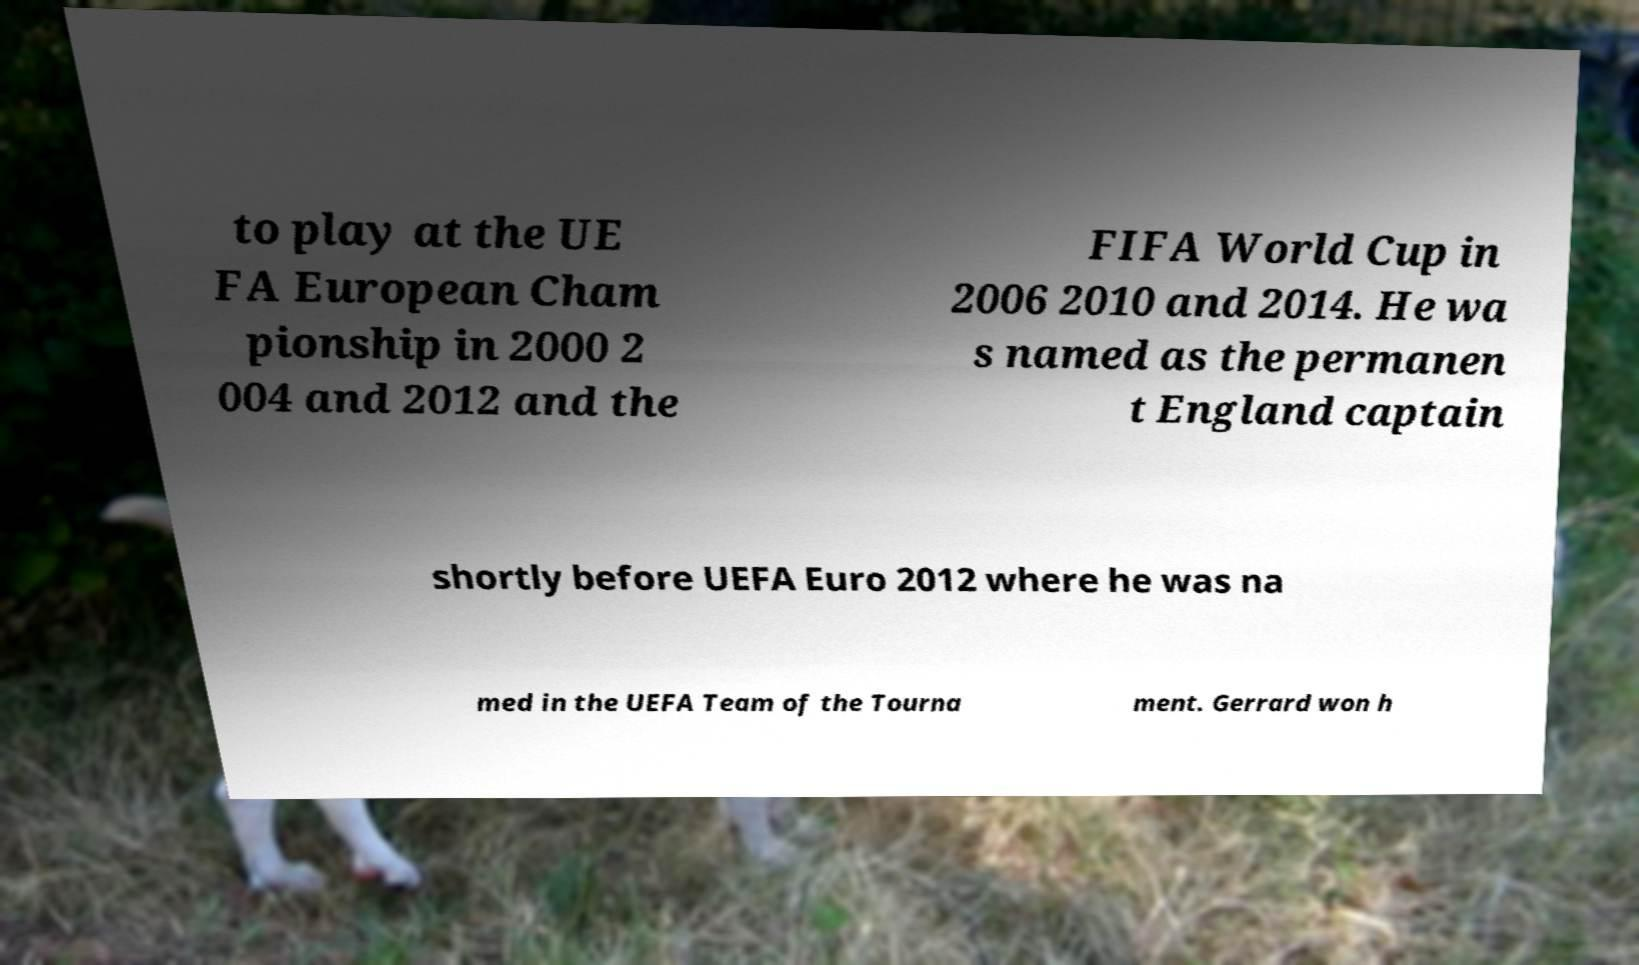Can you accurately transcribe the text from the provided image for me? to play at the UE FA European Cham pionship in 2000 2 004 and 2012 and the FIFA World Cup in 2006 2010 and 2014. He wa s named as the permanen t England captain shortly before UEFA Euro 2012 where he was na med in the UEFA Team of the Tourna ment. Gerrard won h 